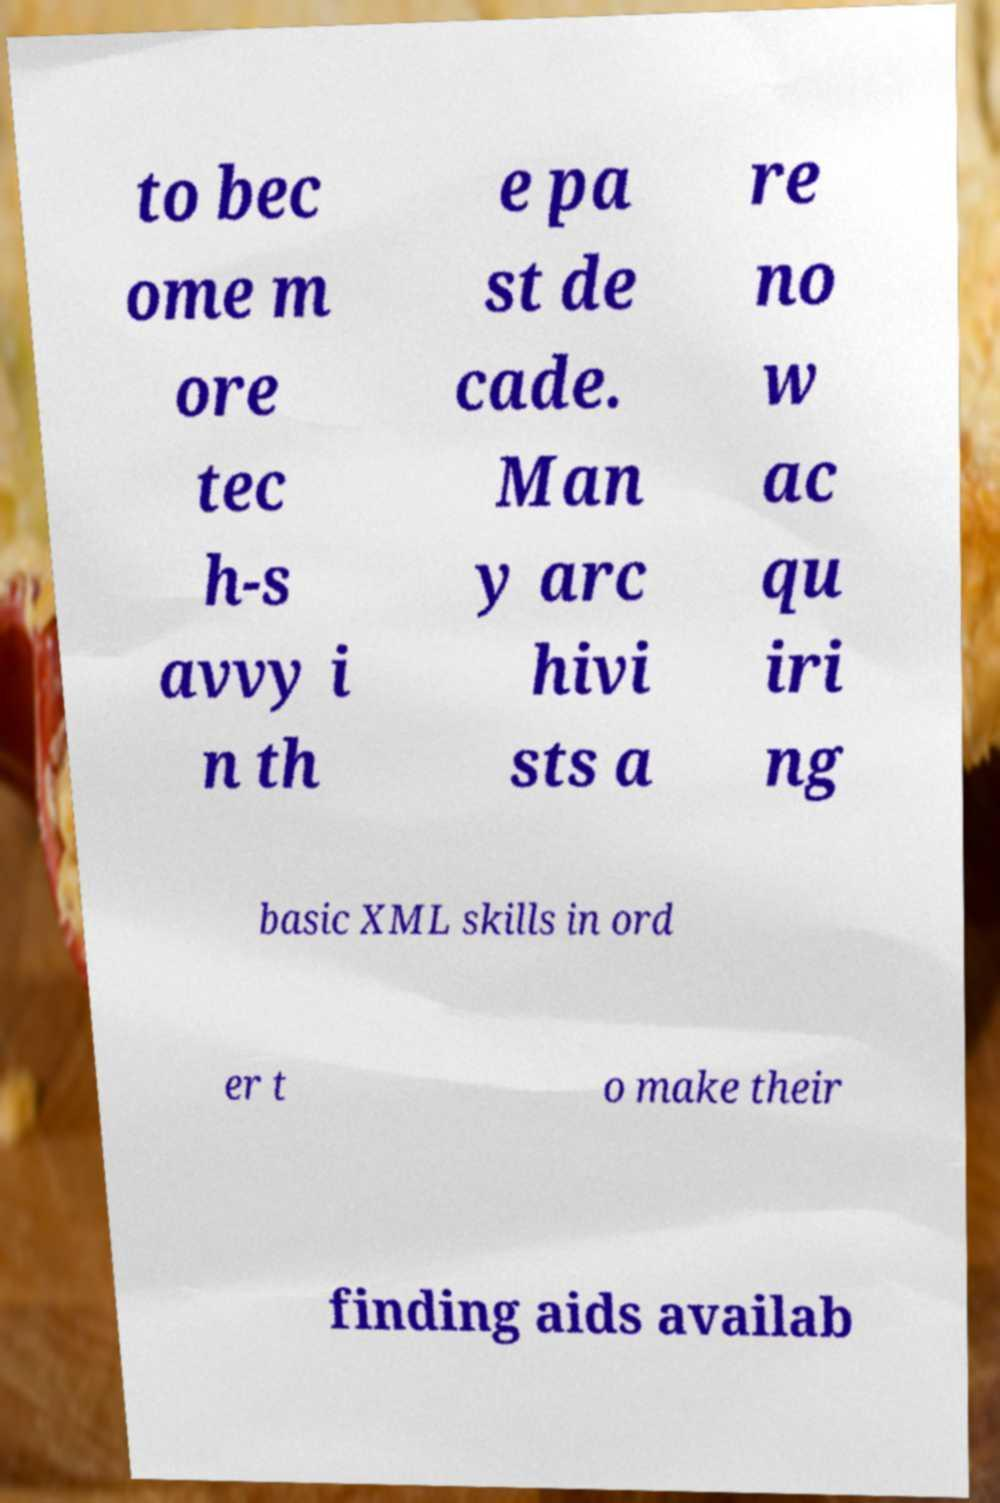Can you accurately transcribe the text from the provided image for me? to bec ome m ore tec h-s avvy i n th e pa st de cade. Man y arc hivi sts a re no w ac qu iri ng basic XML skills in ord er t o make their finding aids availab 